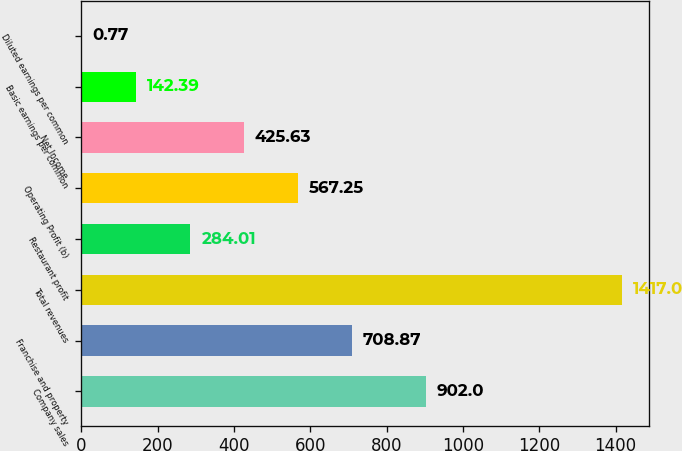Convert chart. <chart><loc_0><loc_0><loc_500><loc_500><bar_chart><fcel>Company sales<fcel>Franchise and property<fcel>Total revenues<fcel>Restaurant profit<fcel>Operating Profit (b)<fcel>Net Income<fcel>Basic earnings per common<fcel>Diluted earnings per common<nl><fcel>902<fcel>708.87<fcel>1417<fcel>284.01<fcel>567.25<fcel>425.63<fcel>142.39<fcel>0.77<nl></chart> 